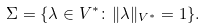<formula> <loc_0><loc_0><loc_500><loc_500>\Sigma = \{ \lambda \in V ^ { * } \colon \| \lambda \| _ { V ^ { * } } = 1 \} .</formula> 